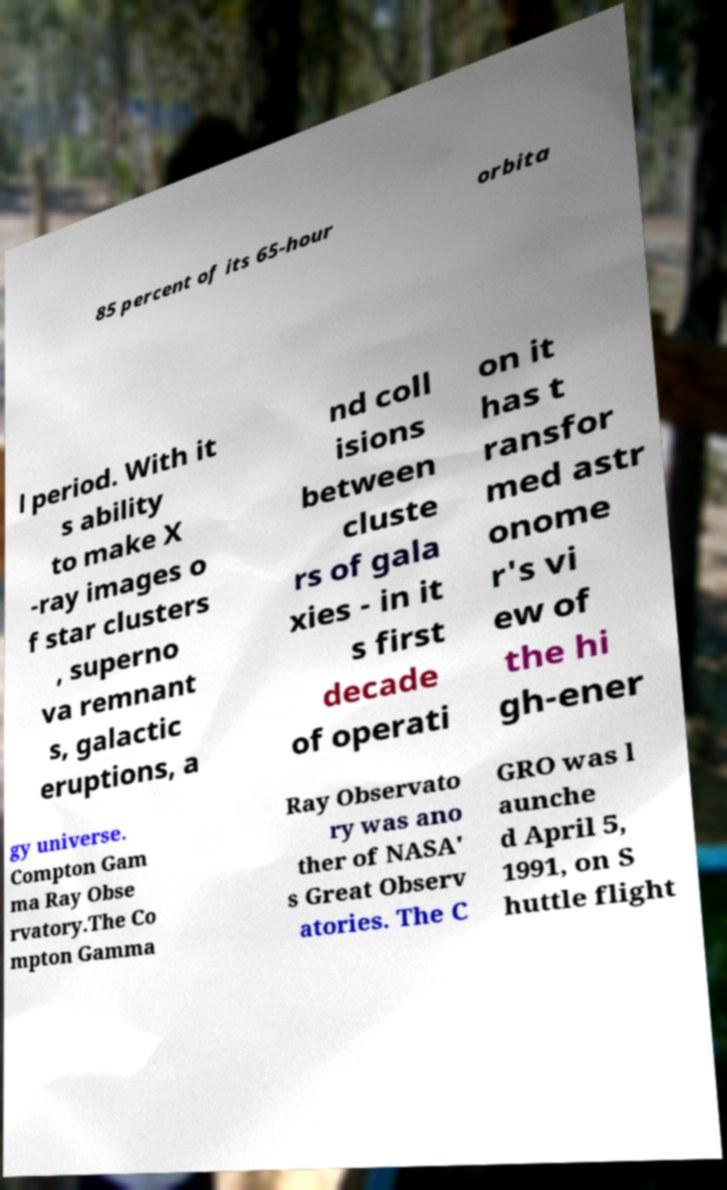There's text embedded in this image that I need extracted. Can you transcribe it verbatim? 85 percent of its 65-hour orbita l period. With it s ability to make X -ray images o f star clusters , superno va remnant s, galactic eruptions, a nd coll isions between cluste rs of gala xies - in it s first decade of operati on it has t ransfor med astr onome r's vi ew of the hi gh-ener gy universe. Compton Gam ma Ray Obse rvatory.The Co mpton Gamma Ray Observato ry was ano ther of NASA' s Great Observ atories. The C GRO was l aunche d April 5, 1991, on S huttle flight 